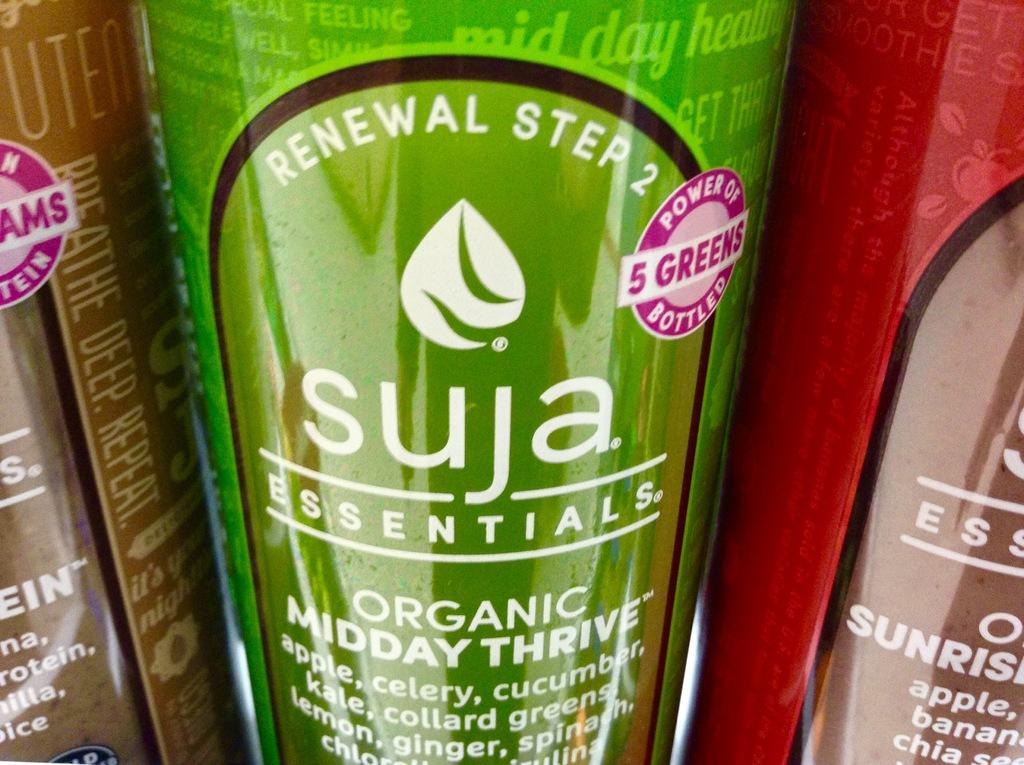Provide a one-sentence caption for the provided image. the organic thrive drink  displayed  and the brand name of  Suja essential brand. 